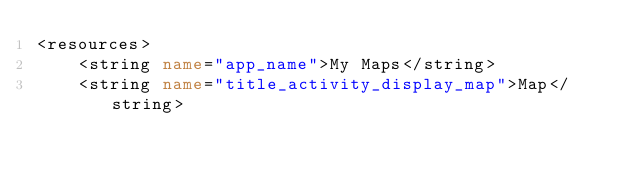<code> <loc_0><loc_0><loc_500><loc_500><_XML_><resources>
    <string name="app_name">My Maps</string>
    <string name="title_activity_display_map">Map</string></code> 